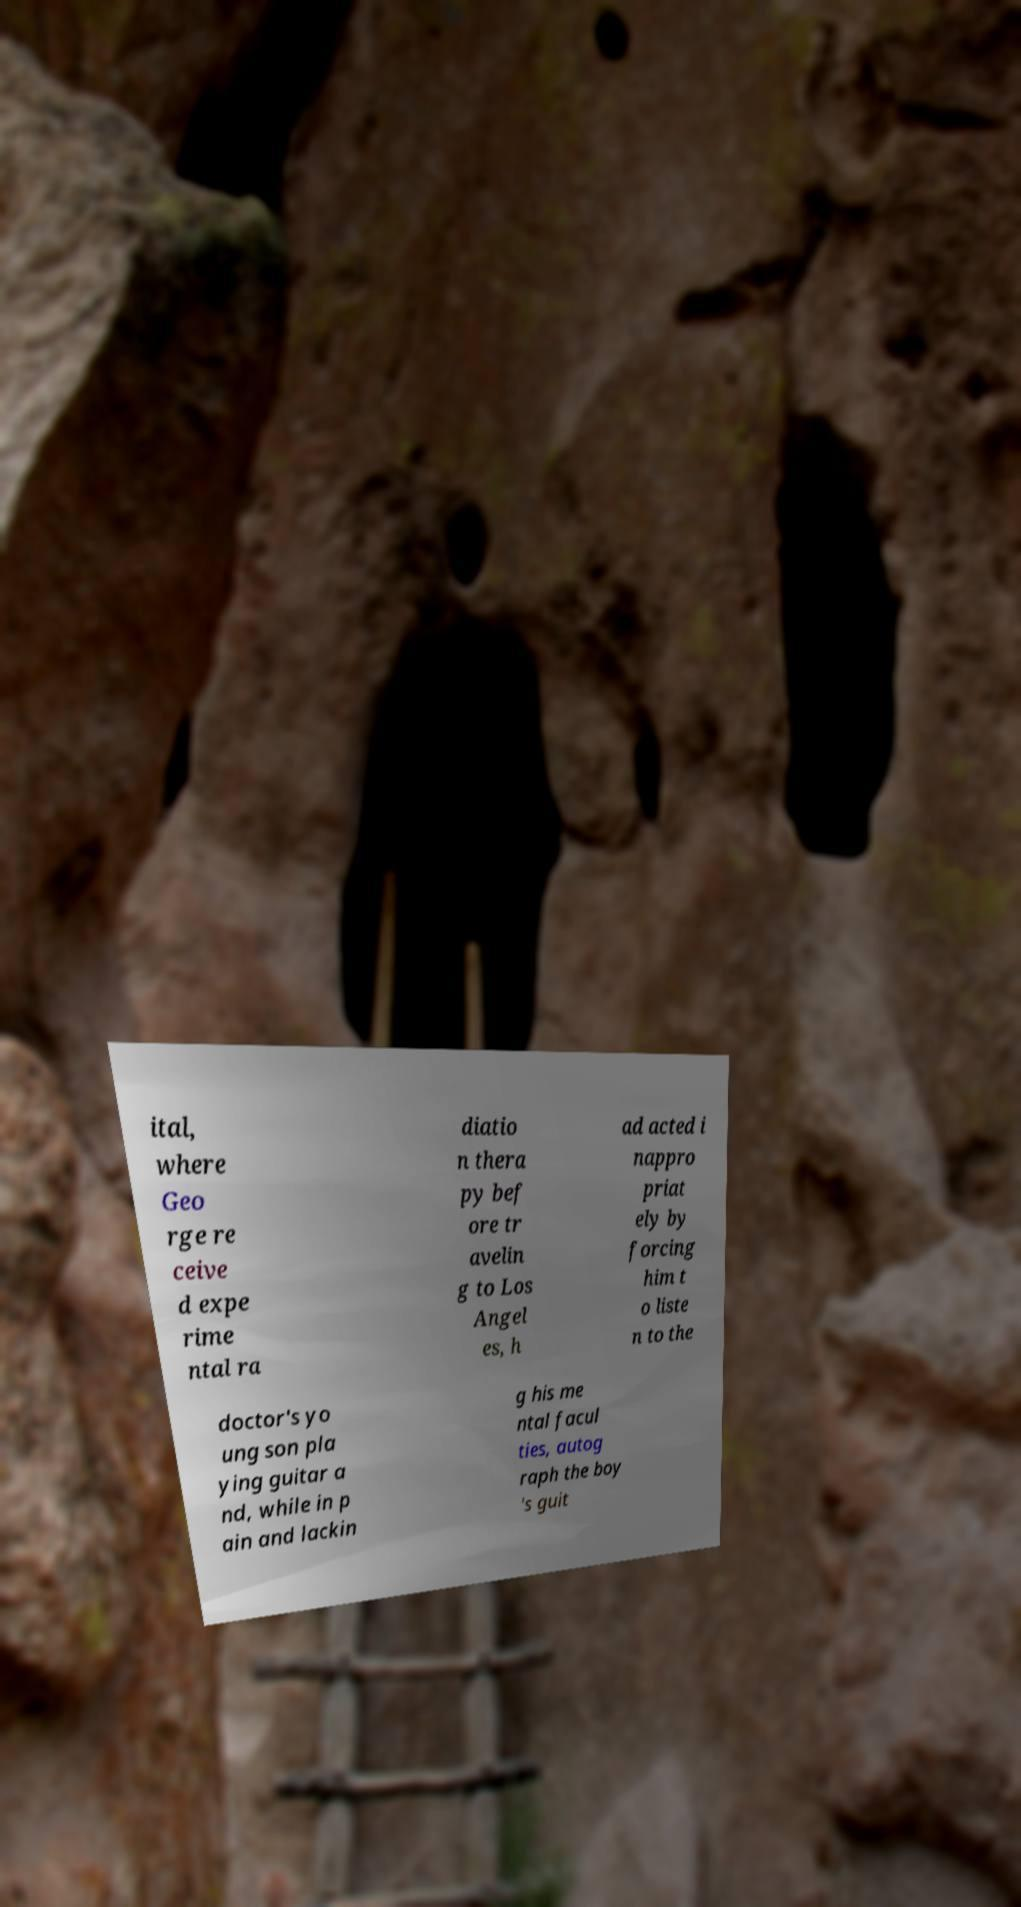There's text embedded in this image that I need extracted. Can you transcribe it verbatim? ital, where Geo rge re ceive d expe rime ntal ra diatio n thera py bef ore tr avelin g to Los Angel es, h ad acted i nappro priat ely by forcing him t o liste n to the doctor's yo ung son pla ying guitar a nd, while in p ain and lackin g his me ntal facul ties, autog raph the boy 's guit 